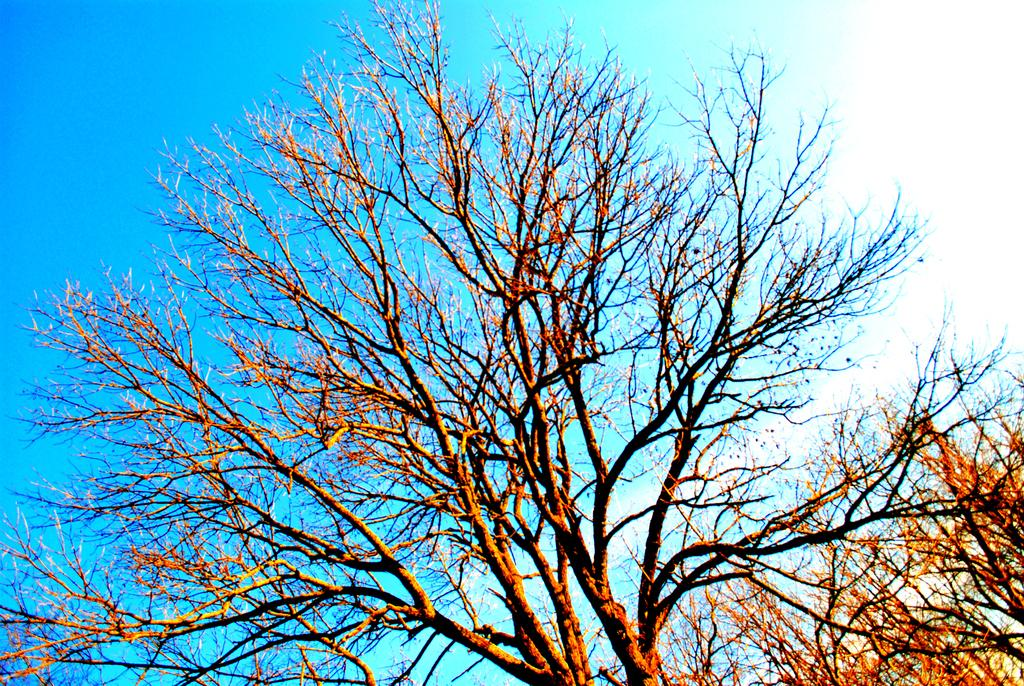What type of vegetation can be seen in the image? There are trees in the image. What part of the natural environment is visible in the image? The sky is visible in the background of the image. What type of voice can be heard coming from the trees in the image? There is no voice present in the image, as trees do not have the ability to produce sound. 